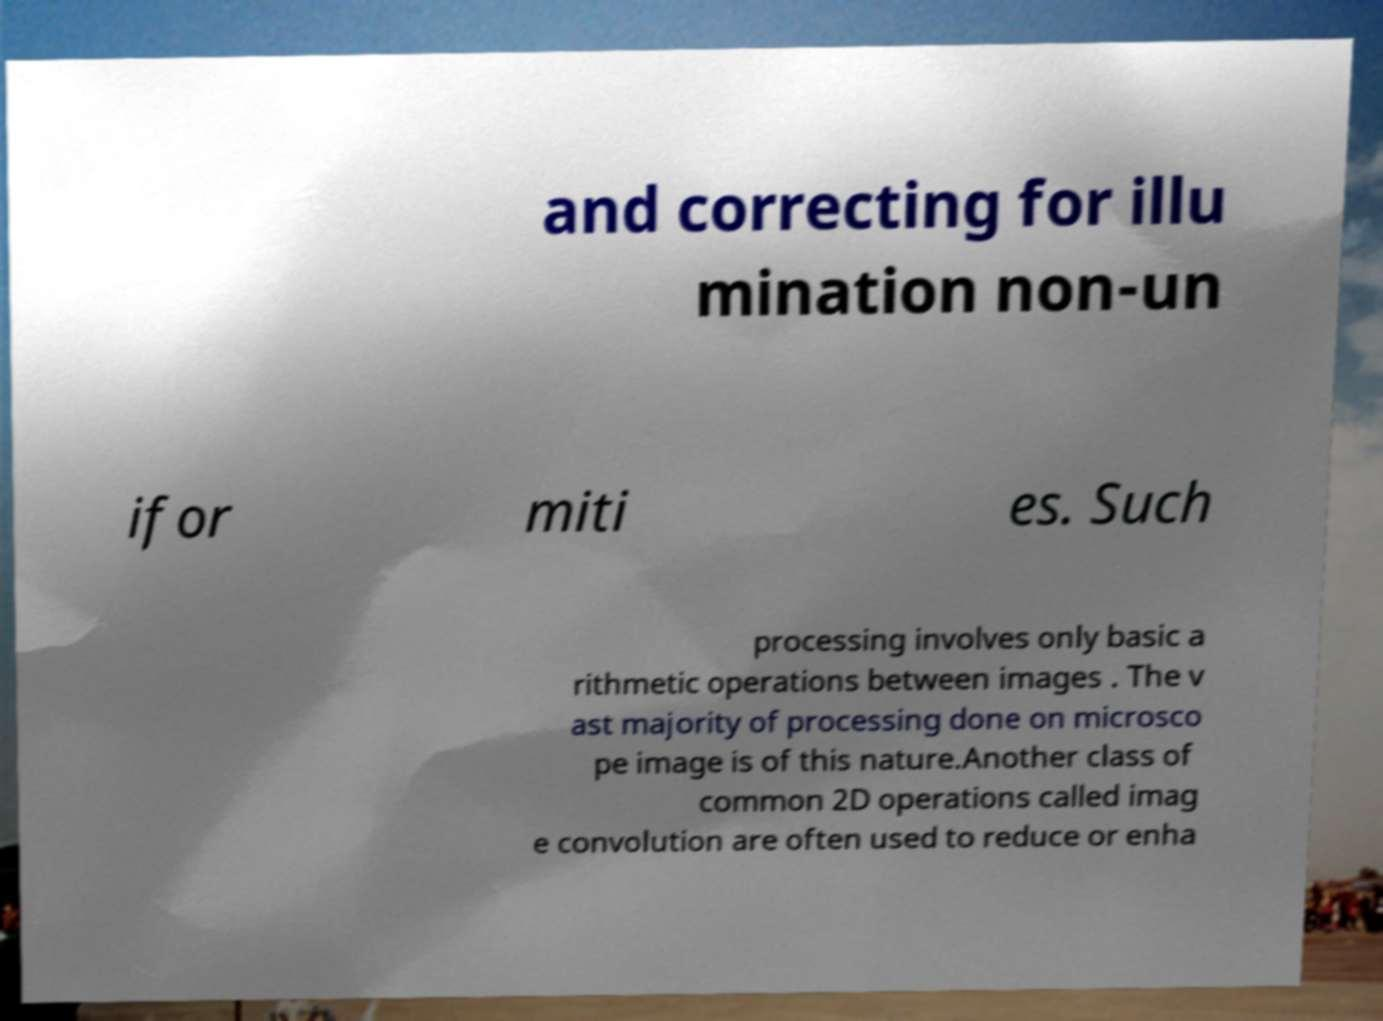There's text embedded in this image that I need extracted. Can you transcribe it verbatim? and correcting for illu mination non-un ifor miti es. Such processing involves only basic a rithmetic operations between images . The v ast majority of processing done on microsco pe image is of this nature.Another class of common 2D operations called imag e convolution are often used to reduce or enha 